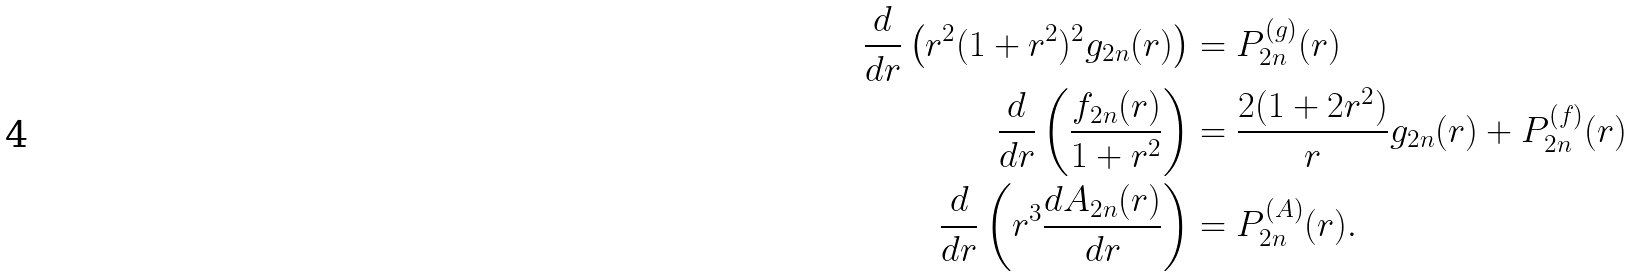<formula> <loc_0><loc_0><loc_500><loc_500>\frac { d } { d r } \left ( r ^ { 2 } ( 1 + r ^ { 2 } ) ^ { 2 } g _ { 2 n } ( r ) \right ) & = P ^ { ( g ) } _ { 2 n } ( r ) \\ \frac { d } { d r } \left ( \frac { f _ { 2 n } ( r ) } { 1 + r ^ { 2 } } \right ) & = \frac { 2 ( 1 + 2 r ^ { 2 } ) } { r } g _ { 2 n } ( r ) + P ^ { ( f ) } _ { 2 n } ( r ) \\ \frac { d } { d r } \left ( r ^ { 3 } \frac { d A _ { 2 n } ( r ) } { d r } \right ) & = P ^ { ( A ) } _ { 2 n } ( r ) . \\</formula> 